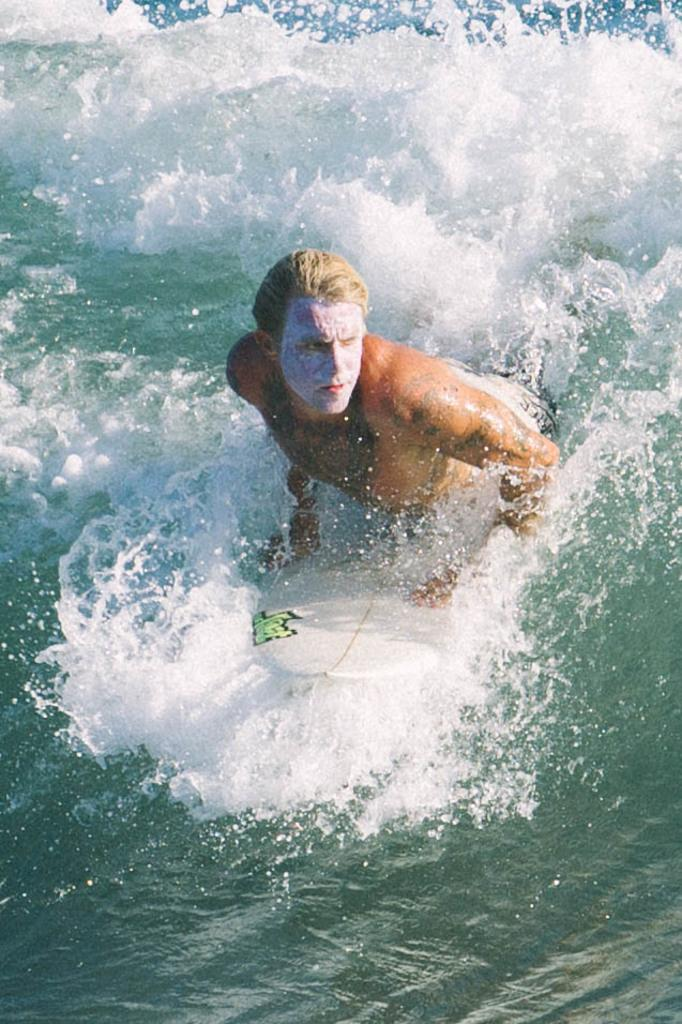Who is in the image? There is a man in the image. What is the man doing in the image? The man is on a surfing board. What is the setting of the image? There is water visible in the image. How many horses are visible in the image? There are no horses present in the image. What type of property does the man own in the image? The image does not show any property owned by the man. 